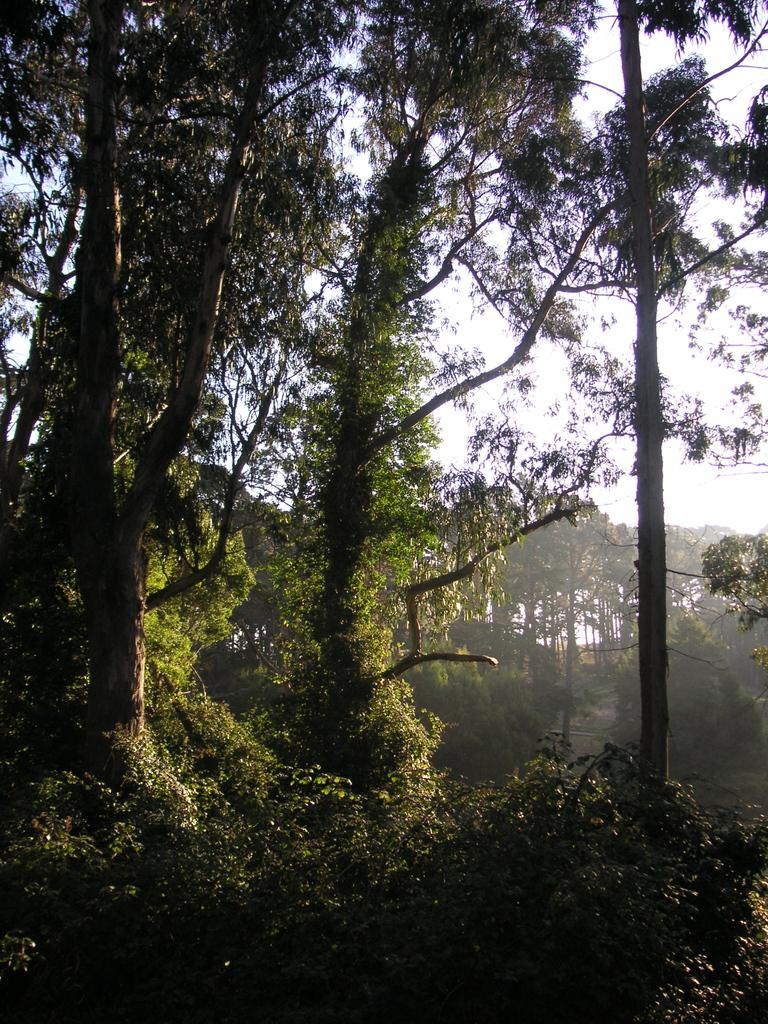What type of vegetation can be seen in the image? There is a plant and trees visible in the image. Can you describe the trees in the image? There are trees in the image, and there are also trees in the background of the image. What is visible in the background of the image? The sky is visible in the background of the image. What type of glass can be seen in the image? There is no glass present in the image. Can you describe the way the owl is flying in the image? There is no owl present in the image, so it cannot be described flying or performing any action. 